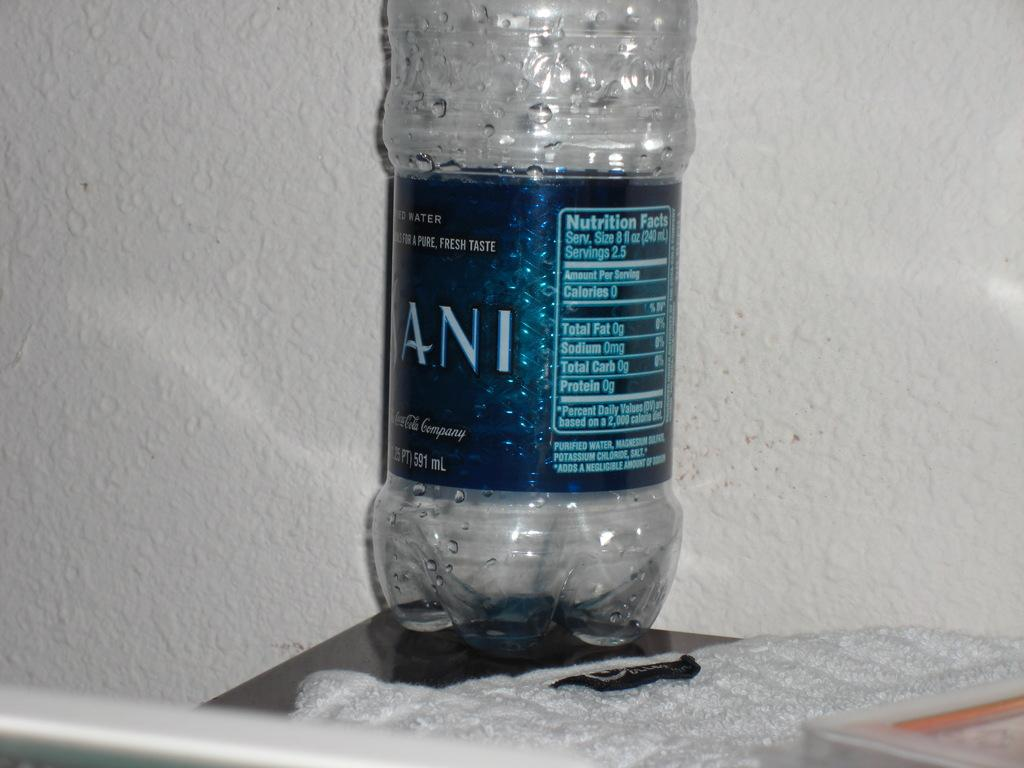<image>
Describe the image concisely. A Dasani water bottle sits on the corner of a dark table. 